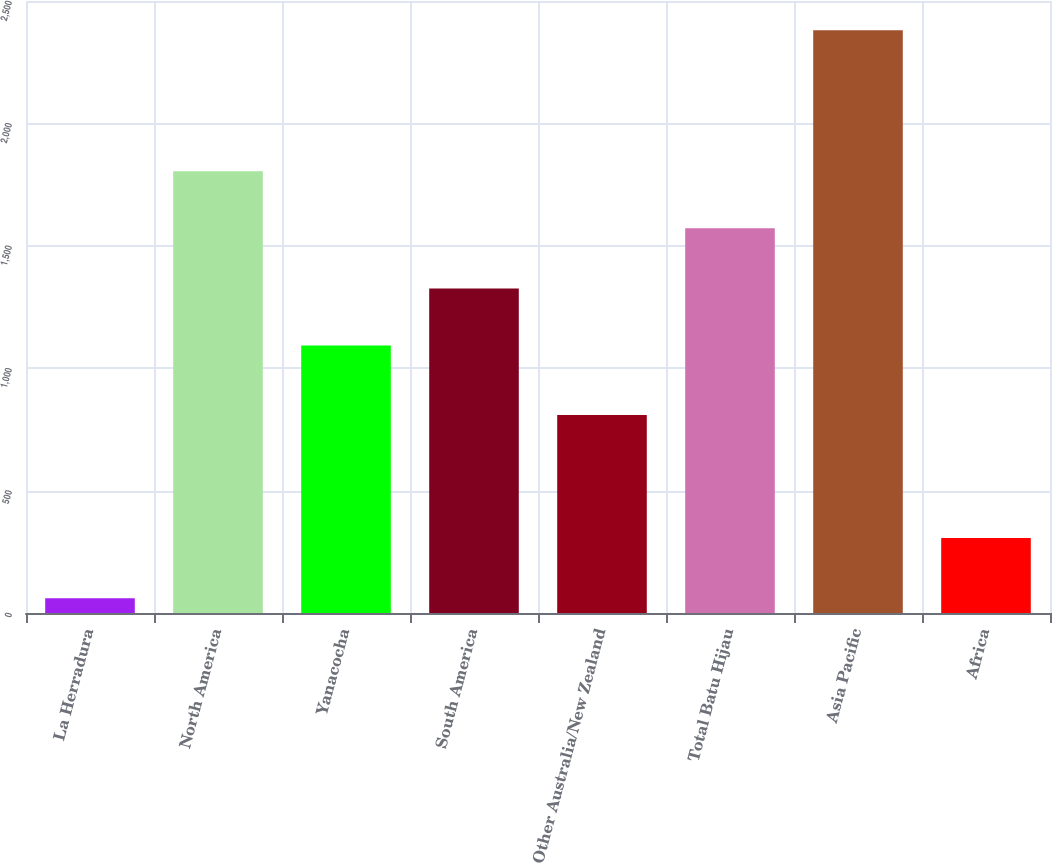Convert chart. <chart><loc_0><loc_0><loc_500><loc_500><bar_chart><fcel>La Herradura<fcel>North America<fcel>Yanacocha<fcel>South America<fcel>Other Australia/New Zealand<fcel>Total Batu Hijau<fcel>Asia Pacific<fcel>Africa<nl><fcel>60<fcel>1804.1<fcel>1093<fcel>1325.1<fcel>809<fcel>1572<fcel>2381<fcel>306<nl></chart> 